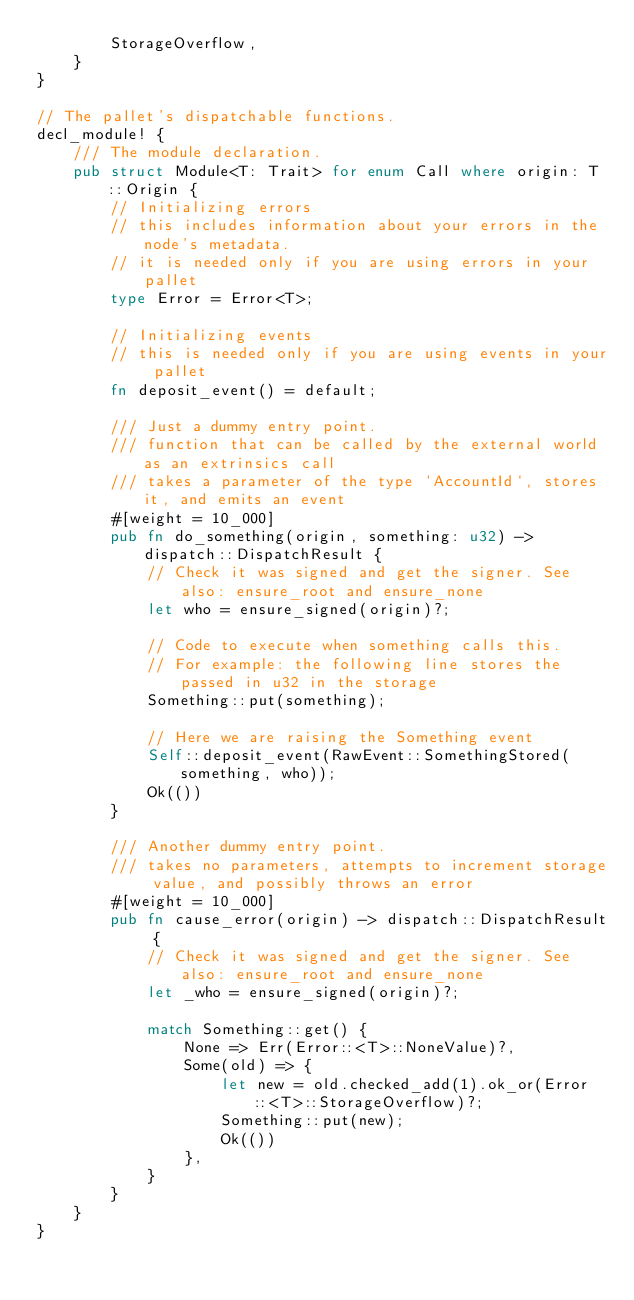<code> <loc_0><loc_0><loc_500><loc_500><_Rust_>		StorageOverflow,
	}
}

// The pallet's dispatchable functions.
decl_module! {
	/// The module declaration.
	pub struct Module<T: Trait> for enum Call where origin: T::Origin {
		// Initializing errors
		// this includes information about your errors in the node's metadata.
		// it is needed only if you are using errors in your pallet
		type Error = Error<T>;

		// Initializing events
		// this is needed only if you are using events in your pallet
		fn deposit_event() = default;

		/// Just a dummy entry point.
		/// function that can be called by the external world as an extrinsics call
		/// takes a parameter of the type `AccountId`, stores it, and emits an event
		#[weight = 10_000]
		pub fn do_something(origin, something: u32) -> dispatch::DispatchResult {
			// Check it was signed and get the signer. See also: ensure_root and ensure_none
			let who = ensure_signed(origin)?;

			// Code to execute when something calls this.
			// For example: the following line stores the passed in u32 in the storage
			Something::put(something);

			// Here we are raising the Something event
			Self::deposit_event(RawEvent::SomethingStored(something, who));
			Ok(())
		}

		/// Another dummy entry point.
		/// takes no parameters, attempts to increment storage value, and possibly throws an error
		#[weight = 10_000]
		pub fn cause_error(origin) -> dispatch::DispatchResult {
			// Check it was signed and get the signer. See also: ensure_root and ensure_none
			let _who = ensure_signed(origin)?;

			match Something::get() {
				None => Err(Error::<T>::NoneValue)?,
				Some(old) => {
					let new = old.checked_add(1).ok_or(Error::<T>::StorageOverflow)?;
					Something::put(new);
					Ok(())
				},
			}
		}
	}
}
</code> 